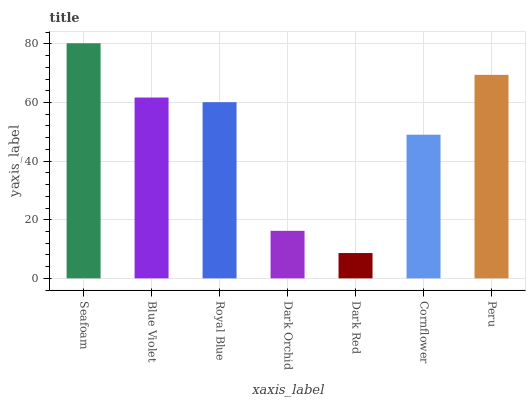Is Dark Red the minimum?
Answer yes or no. Yes. Is Seafoam the maximum?
Answer yes or no. Yes. Is Blue Violet the minimum?
Answer yes or no. No. Is Blue Violet the maximum?
Answer yes or no. No. Is Seafoam greater than Blue Violet?
Answer yes or no. Yes. Is Blue Violet less than Seafoam?
Answer yes or no. Yes. Is Blue Violet greater than Seafoam?
Answer yes or no. No. Is Seafoam less than Blue Violet?
Answer yes or no. No. Is Royal Blue the high median?
Answer yes or no. Yes. Is Royal Blue the low median?
Answer yes or no. Yes. Is Dark Red the high median?
Answer yes or no. No. Is Peru the low median?
Answer yes or no. No. 